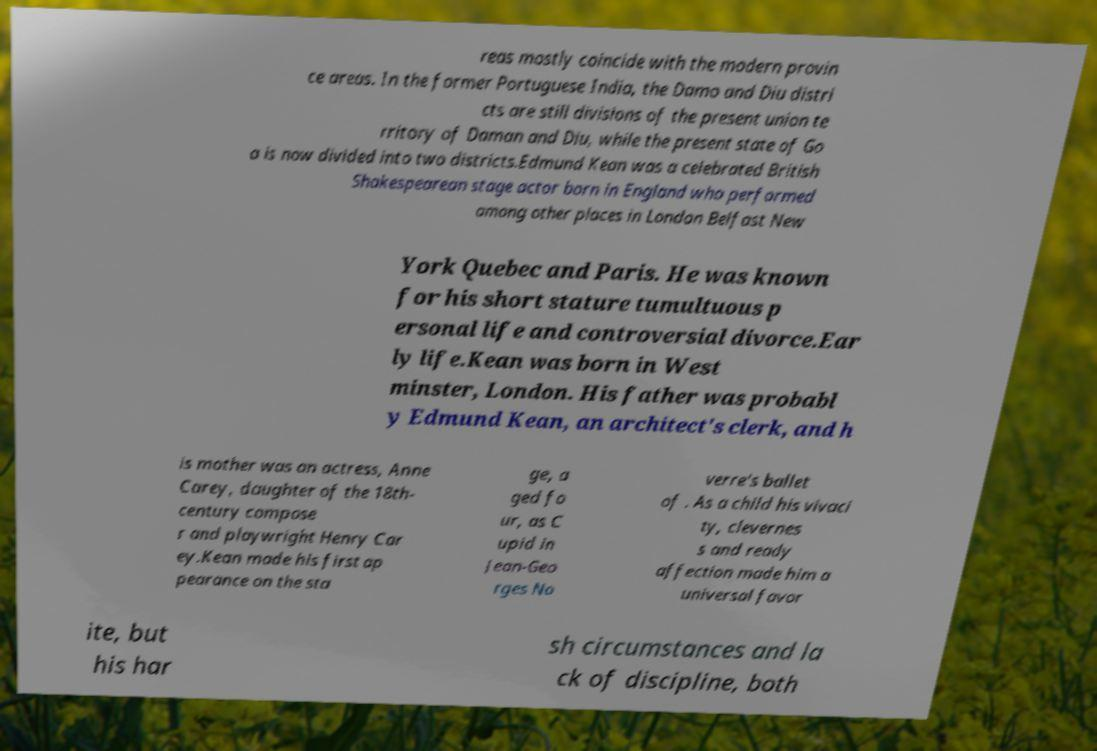Please read and relay the text visible in this image. What does it say? reas mostly coincide with the modern provin ce areas. In the former Portuguese India, the Damo and Diu distri cts are still divisions of the present union te rritory of Daman and Diu, while the present state of Go a is now divided into two districts.Edmund Kean was a celebrated British Shakespearean stage actor born in England who performed among other places in London Belfast New York Quebec and Paris. He was known for his short stature tumultuous p ersonal life and controversial divorce.Ear ly life.Kean was born in West minster, London. His father was probabl y Edmund Kean, an architect's clerk, and h is mother was an actress, Anne Carey, daughter of the 18th- century compose r and playwright Henry Car ey.Kean made his first ap pearance on the sta ge, a ged fo ur, as C upid in Jean-Geo rges No verre's ballet of . As a child his vivaci ty, clevernes s and ready affection made him a universal favor ite, but his har sh circumstances and la ck of discipline, both 